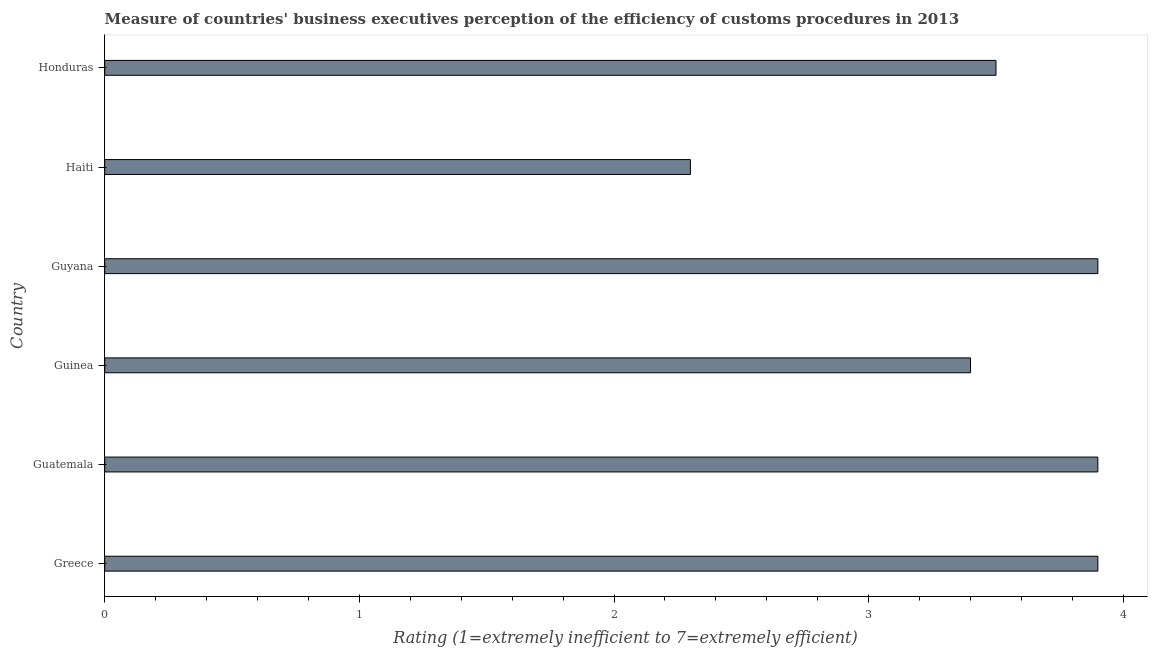Does the graph contain any zero values?
Give a very brief answer. No. Does the graph contain grids?
Provide a short and direct response. No. What is the title of the graph?
Provide a short and direct response. Measure of countries' business executives perception of the efficiency of customs procedures in 2013. What is the label or title of the X-axis?
Give a very brief answer. Rating (1=extremely inefficient to 7=extremely efficient). In which country was the rating measuring burden of customs procedure minimum?
Your answer should be compact. Haiti. What is the sum of the rating measuring burden of customs procedure?
Make the answer very short. 20.9. What is the difference between the rating measuring burden of customs procedure in Guatemala and Guyana?
Offer a very short reply. 0. What is the average rating measuring burden of customs procedure per country?
Keep it short and to the point. 3.48. What is the median rating measuring burden of customs procedure?
Make the answer very short. 3.7. What is the ratio of the rating measuring burden of customs procedure in Guyana to that in Haiti?
Your answer should be very brief. 1.7. Is the rating measuring burden of customs procedure in Guinea less than that in Guyana?
Provide a short and direct response. Yes. Is the difference between the rating measuring burden of customs procedure in Guyana and Honduras greater than the difference between any two countries?
Provide a short and direct response. No. What is the difference between the highest and the second highest rating measuring burden of customs procedure?
Offer a terse response. 0. In how many countries, is the rating measuring burden of customs procedure greater than the average rating measuring burden of customs procedure taken over all countries?
Your answer should be compact. 4. How many bars are there?
Give a very brief answer. 6. How many countries are there in the graph?
Offer a very short reply. 6. Are the values on the major ticks of X-axis written in scientific E-notation?
Ensure brevity in your answer.  No. What is the Rating (1=extremely inefficient to 7=extremely efficient) in Greece?
Provide a short and direct response. 3.9. What is the Rating (1=extremely inefficient to 7=extremely efficient) of Honduras?
Keep it short and to the point. 3.5. What is the difference between the Rating (1=extremely inefficient to 7=extremely efficient) in Greece and Guyana?
Keep it short and to the point. 0. What is the difference between the Rating (1=extremely inefficient to 7=extremely efficient) in Guatemala and Guinea?
Give a very brief answer. 0.5. What is the difference between the Rating (1=extremely inefficient to 7=extremely efficient) in Guatemala and Guyana?
Provide a succinct answer. 0. What is the difference between the Rating (1=extremely inefficient to 7=extremely efficient) in Guatemala and Honduras?
Offer a very short reply. 0.4. What is the difference between the Rating (1=extremely inefficient to 7=extremely efficient) in Guinea and Guyana?
Make the answer very short. -0.5. What is the difference between the Rating (1=extremely inefficient to 7=extremely efficient) in Guinea and Haiti?
Provide a succinct answer. 1.1. What is the difference between the Rating (1=extremely inefficient to 7=extremely efficient) in Guyana and Haiti?
Your response must be concise. 1.6. What is the difference between the Rating (1=extremely inefficient to 7=extremely efficient) in Haiti and Honduras?
Ensure brevity in your answer.  -1.2. What is the ratio of the Rating (1=extremely inefficient to 7=extremely efficient) in Greece to that in Guinea?
Offer a very short reply. 1.15. What is the ratio of the Rating (1=extremely inefficient to 7=extremely efficient) in Greece to that in Haiti?
Your answer should be very brief. 1.7. What is the ratio of the Rating (1=extremely inefficient to 7=extremely efficient) in Greece to that in Honduras?
Provide a short and direct response. 1.11. What is the ratio of the Rating (1=extremely inefficient to 7=extremely efficient) in Guatemala to that in Guinea?
Provide a succinct answer. 1.15. What is the ratio of the Rating (1=extremely inefficient to 7=extremely efficient) in Guatemala to that in Haiti?
Offer a very short reply. 1.7. What is the ratio of the Rating (1=extremely inefficient to 7=extremely efficient) in Guatemala to that in Honduras?
Your answer should be very brief. 1.11. What is the ratio of the Rating (1=extremely inefficient to 7=extremely efficient) in Guinea to that in Guyana?
Offer a very short reply. 0.87. What is the ratio of the Rating (1=extremely inefficient to 7=extremely efficient) in Guinea to that in Haiti?
Provide a succinct answer. 1.48. What is the ratio of the Rating (1=extremely inefficient to 7=extremely efficient) in Guinea to that in Honduras?
Your response must be concise. 0.97. What is the ratio of the Rating (1=extremely inefficient to 7=extremely efficient) in Guyana to that in Haiti?
Your answer should be very brief. 1.7. What is the ratio of the Rating (1=extremely inefficient to 7=extremely efficient) in Guyana to that in Honduras?
Your response must be concise. 1.11. What is the ratio of the Rating (1=extremely inefficient to 7=extremely efficient) in Haiti to that in Honduras?
Give a very brief answer. 0.66. 